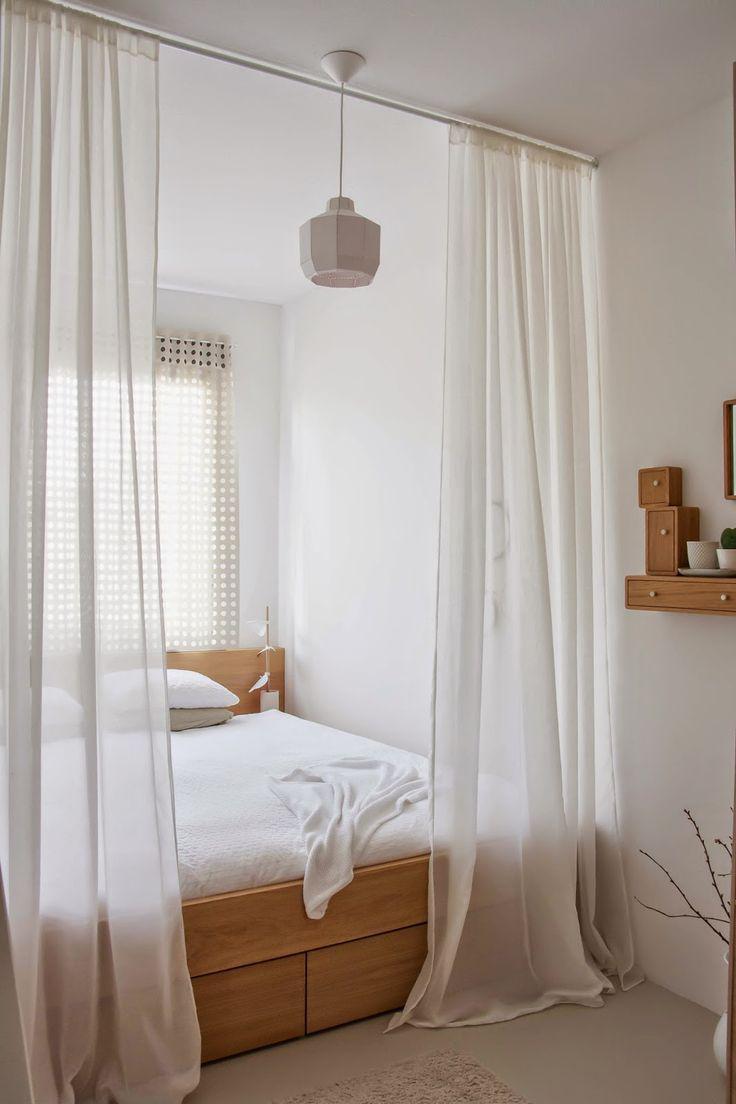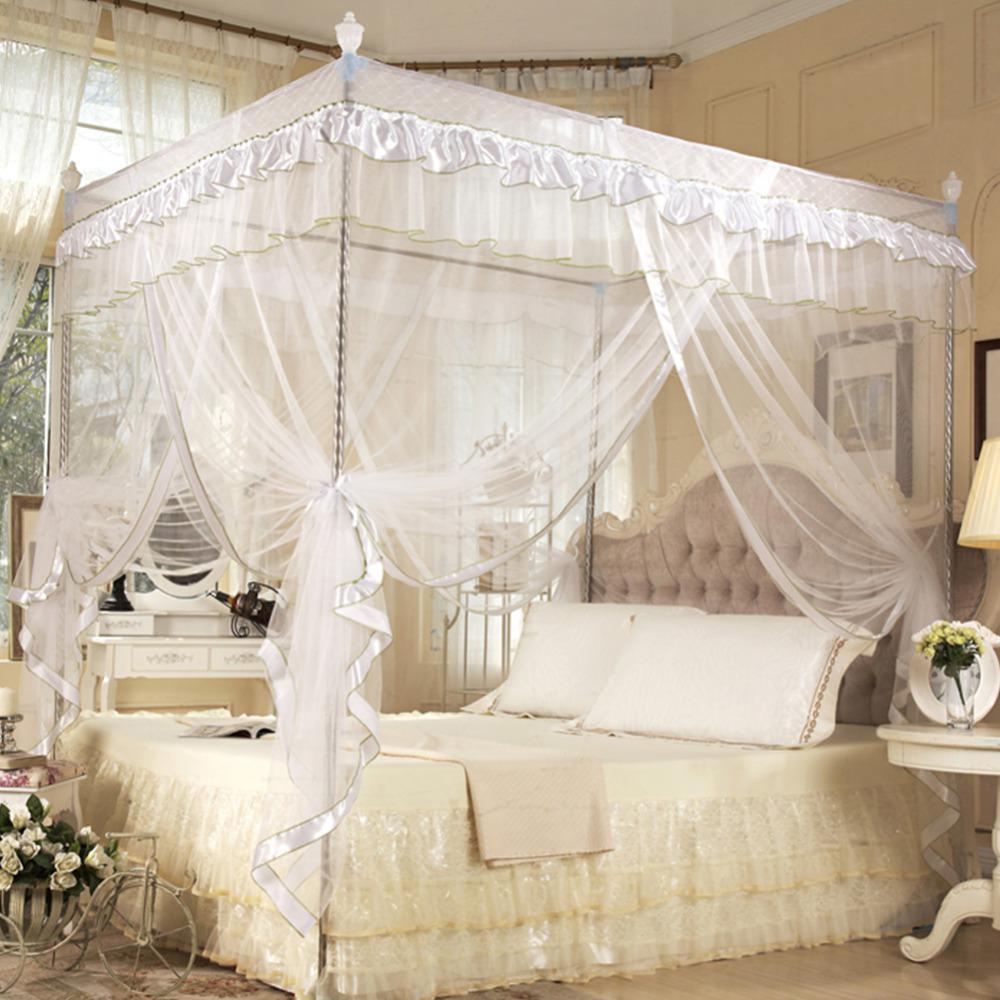The first image is the image on the left, the second image is the image on the right. Given the left and right images, does the statement "Both images show four-posted beds with curtain type canopies." hold true? Answer yes or no. No. 